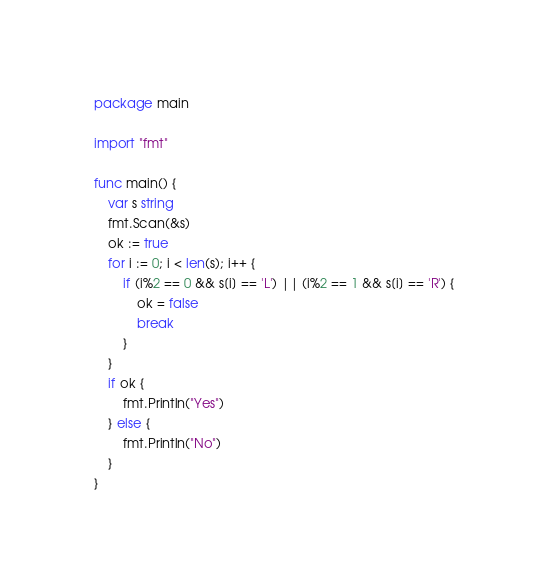<code> <loc_0><loc_0><loc_500><loc_500><_Go_>package main

import "fmt"

func main() {
	var s string
	fmt.Scan(&s)
	ok := true
	for i := 0; i < len(s); i++ {
		if (i%2 == 0 && s[i] == 'L') || (i%2 == 1 && s[i] == 'R') {
			ok = false
			break
		}
	}
	if ok {
		fmt.Println("Yes")
	} else {
		fmt.Println("No")
	}
}
</code> 